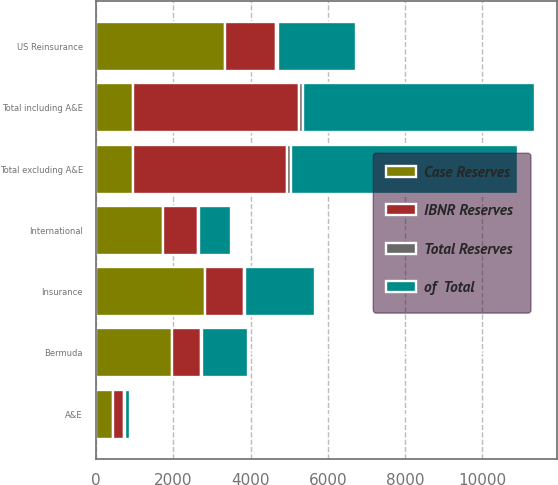Convert chart to OTSL. <chart><loc_0><loc_0><loc_500><loc_500><stacked_bar_chart><ecel><fcel>US Reinsurance<fcel>International<fcel>Bermuda<fcel>Insurance<fcel>Total excluding A&E<fcel>A&E<fcel>Total including A&E<nl><fcel>IBNR Reserves<fcel>1316.3<fcel>893.5<fcel>770<fcel>1018.5<fcel>3998.4<fcel>293.5<fcel>4291.9<nl><fcel>of  Total<fcel>2033.9<fcel>850.3<fcel>1189<fcel>1799.5<fcel>5872.8<fcel>147.6<fcel>6020.4<nl><fcel>Case Reserves<fcel>3350.3<fcel>1743.8<fcel>1959.1<fcel>2818.1<fcel>956<fcel>441.1<fcel>956<nl><fcel>Total Reserves<fcel>32.5<fcel>16.9<fcel>19<fcel>27.3<fcel>95.7<fcel>4.3<fcel>100<nl></chart> 